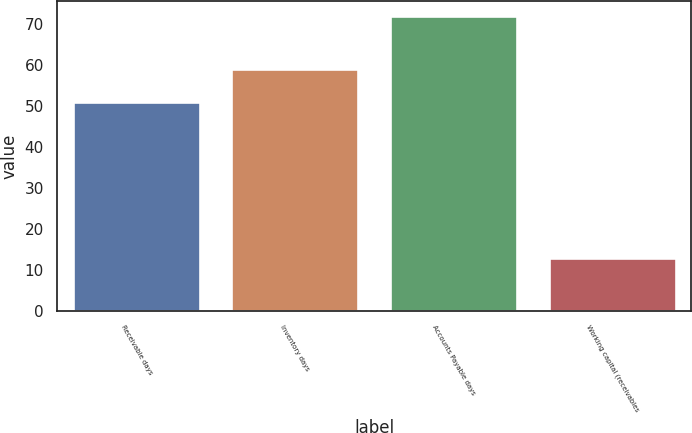Convert chart. <chart><loc_0><loc_0><loc_500><loc_500><bar_chart><fcel>Receivable days<fcel>Inventory days<fcel>Accounts Payable days<fcel>Working capital (receivables<nl><fcel>51<fcel>59<fcel>72<fcel>13<nl></chart> 